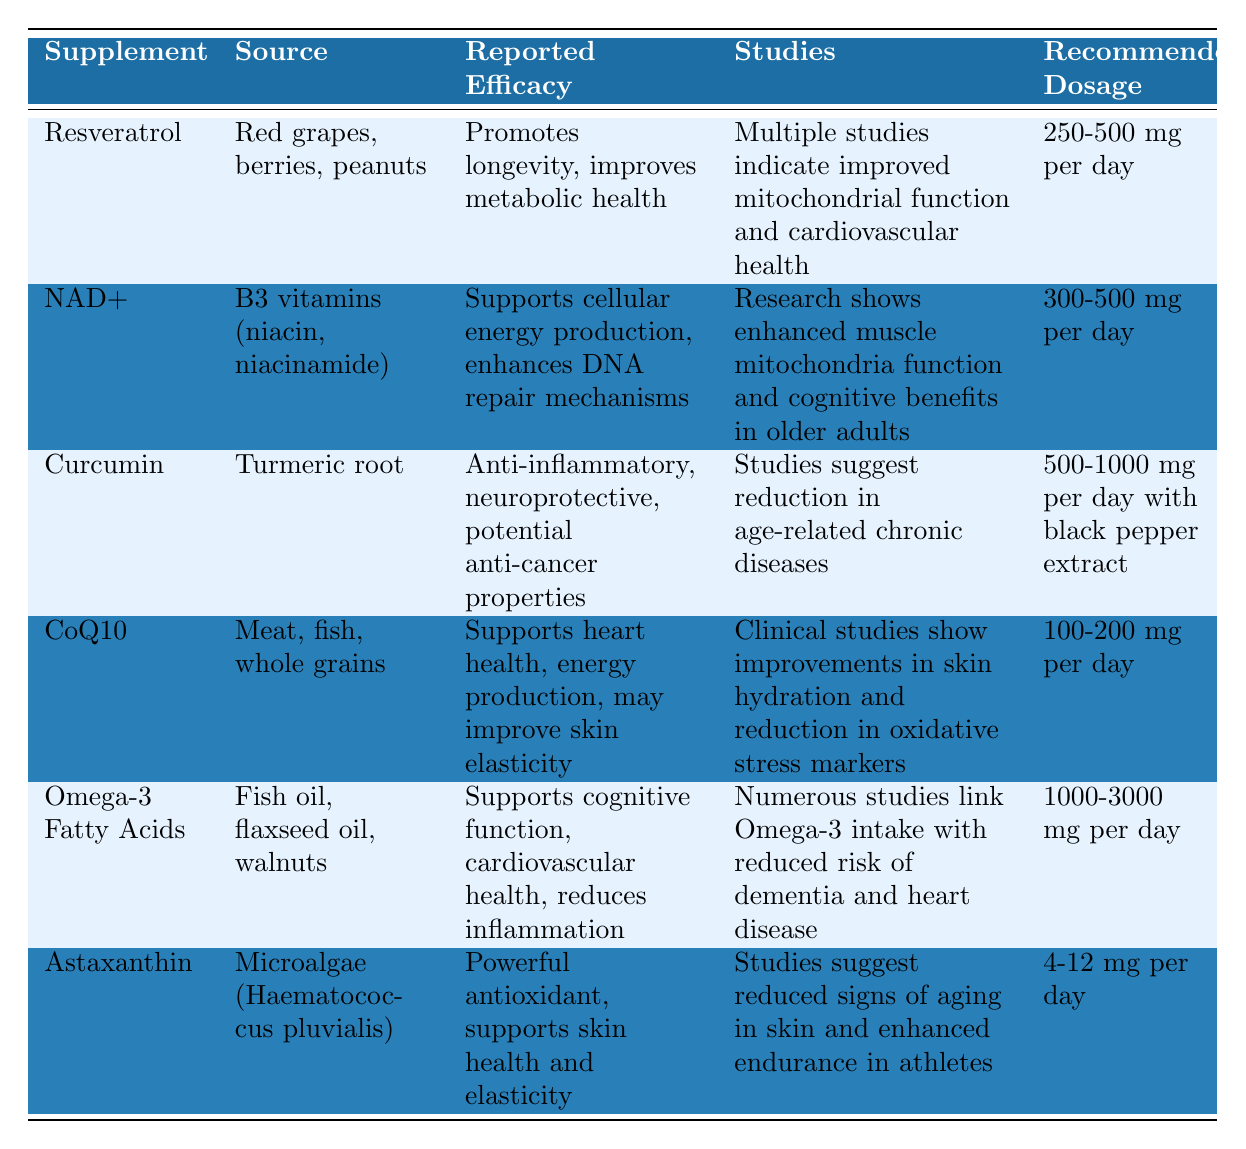What is the source of Coenzyme Q10? The table provides a specific column labeled “Source,” where each supplement's source is listed. For Coenzyme Q10, the source is listed as "Meat, fish, whole grains."
Answer: Meat, fish, whole grains Which supplement has the highest recommended dosage? By examining the “Recommended Dosage” column in the table, Omega-3 Fatty Acids has the highest range of 1000-3000 mg per day.
Answer: Omega-3 Fatty Acids Is Astaxanthin reported to support cognitive function? The “Reported Efficacy” column states that Astaxanthin is a powerful antioxidant that supports skin health. It does not mention cognitive function. Therefore, the answer is no.
Answer: No What is the common role of Resveratrol and Curcumin based on the table? Both Resveratrol and Curcumin are reported to improve health significantly: Resveratrol promotes longevity and metabolic health, while Curcumin is anti-inflammatory and neuroprotective. Therefore, their common role can be categorized as improving overall health.
Answer: Improving overall health What is the average recommended dosage of the supplements listed? To calculate the average, we take the midpoint of the dosages and then find the average: Resveratrol (375), NAD+ (400), Curcumin (750), CoQ10 (150), Omega-3 (2000), Astaxanthin (8). Summing these gives 3683 mg, and dividing by 6 yields an average of approximately 613.83 mg.
Answer: Approximately 613.83 mg Does every supplement listed indicate that it has studies supporting its efficacy? Upon reviewing the “Studies” column, yes, all supplements have supporting studies mentioned to validate their reported efficacy.
Answer: Yes Which supplement's source comes from a plant and a fish? The table shows the sources for each supplement. Omega-3 Fatty Acids includes both fish oil (from fish) and flaxseed oil (from a plant), making it the only supplement with both plant and fish sources.
Answer: Omega-3 Fatty Acids Which two supplements mentioned have reported efficacy related to inflammation? The reported efficacy for both Curcumin (anti-inflammatory) and Omega-3 Fatty Acids (reduces inflammation) relates to inflammation.
Answer: Curcumin and Omega-3 Fatty Acids 